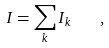<formula> <loc_0><loc_0><loc_500><loc_500>I = \sum _ { k } I _ { k } \quad ,</formula> 